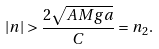Convert formula to latex. <formula><loc_0><loc_0><loc_500><loc_500>| n | > \frac { 2 \sqrt { A M g a } } { C } = n _ { 2 } .</formula> 